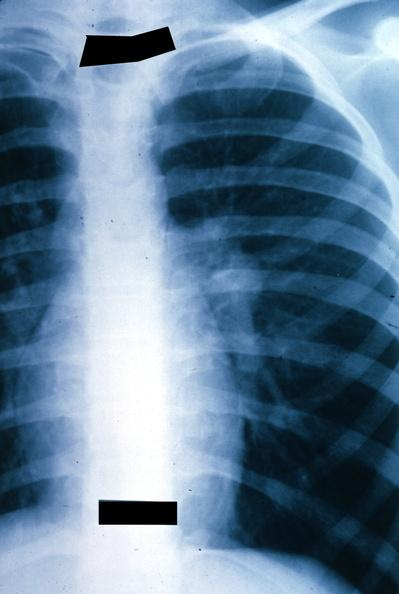what is present?
Answer the question using a single word or phrase. Lung 